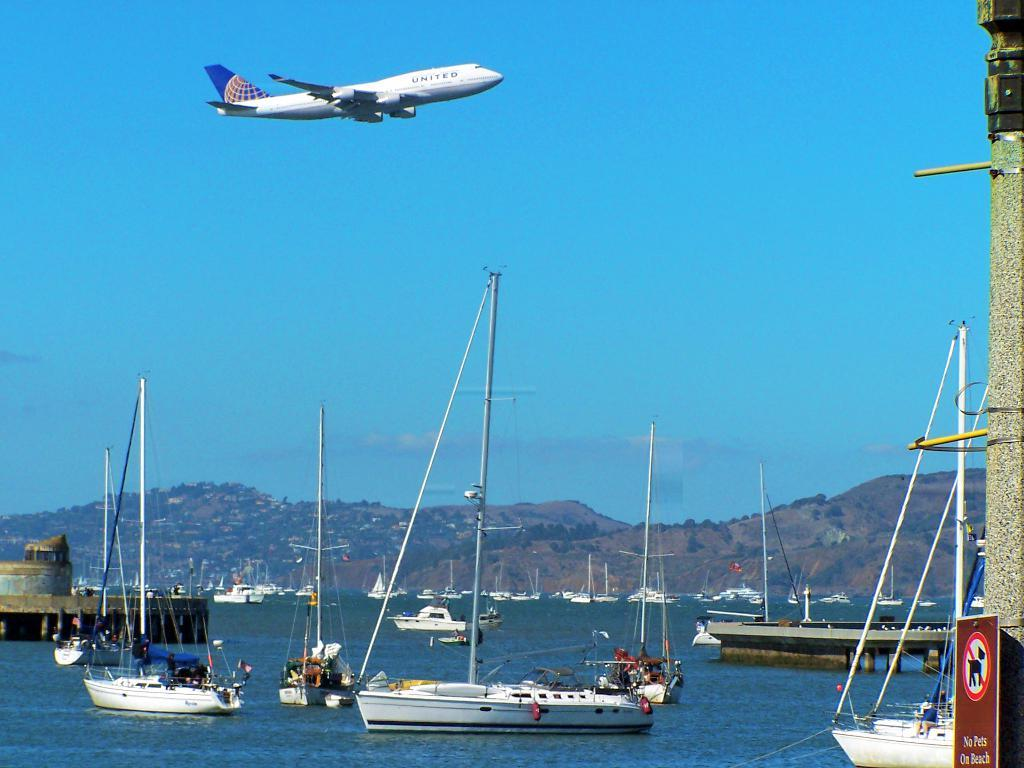Provide a one-sentence caption for the provided image. An airplane with United written on the side flying over a bunch of boats. 